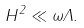<formula> <loc_0><loc_0><loc_500><loc_500>H ^ { 2 } \ll \omega \Lambda .</formula> 